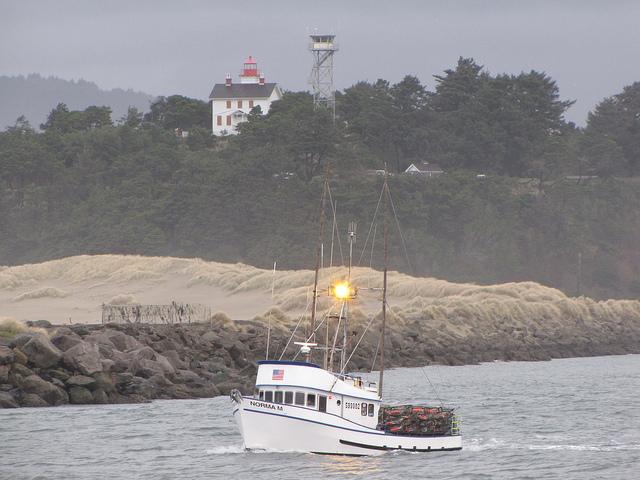Overcast or sunny?
Quick response, please. Overcast. What flag is on the boat?
Short answer required. Usa. Is there a light on the boat?
Keep it brief. Yes. 